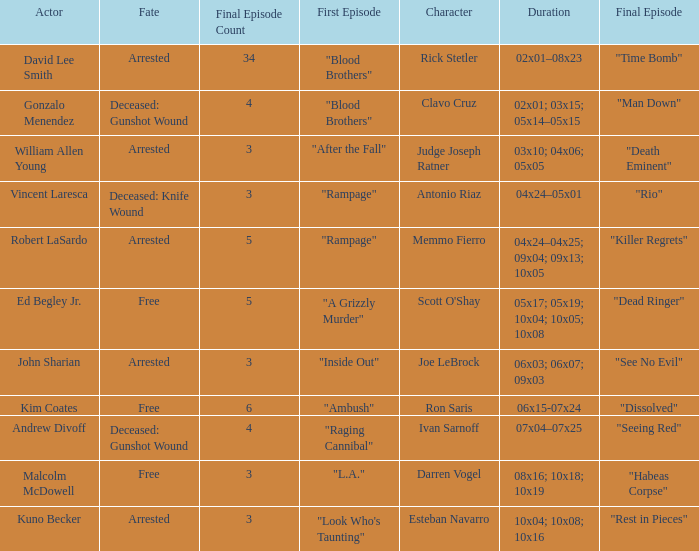What is the character with destiny being dead: knife injury? Antonio Riaz. 